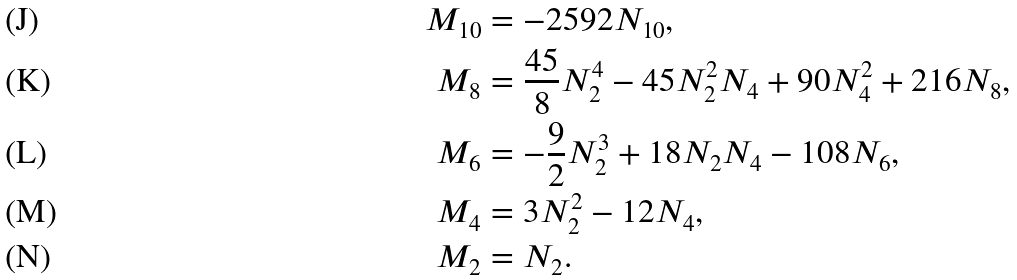<formula> <loc_0><loc_0><loc_500><loc_500>M _ { 1 0 } & = - 2 5 9 2 N _ { 1 0 } , \\ M _ { 8 } & = \frac { 4 5 } { 8 } N _ { 2 } ^ { 4 } - 4 5 N _ { 2 } ^ { 2 } N _ { 4 } + 9 0 N _ { 4 } ^ { 2 } + 2 1 6 N _ { 8 } , \\ M _ { 6 } & = - \frac { 9 } { 2 } N _ { 2 } ^ { 3 } + 1 8 N _ { 2 } N _ { 4 } - 1 0 8 N _ { 6 } , \\ M _ { 4 } & = 3 N _ { 2 } ^ { 2 } - 1 2 N _ { 4 } , \\ M _ { 2 } & = N _ { 2 } .</formula> 